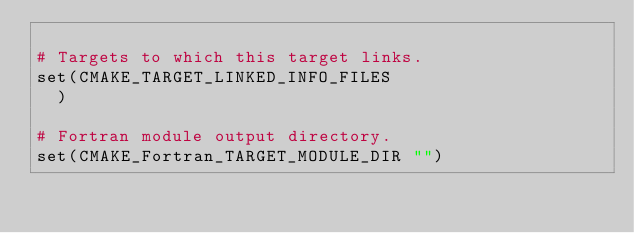<code> <loc_0><loc_0><loc_500><loc_500><_CMake_>
# Targets to which this target links.
set(CMAKE_TARGET_LINKED_INFO_FILES
  )

# Fortran module output directory.
set(CMAKE_Fortran_TARGET_MODULE_DIR "")
</code> 